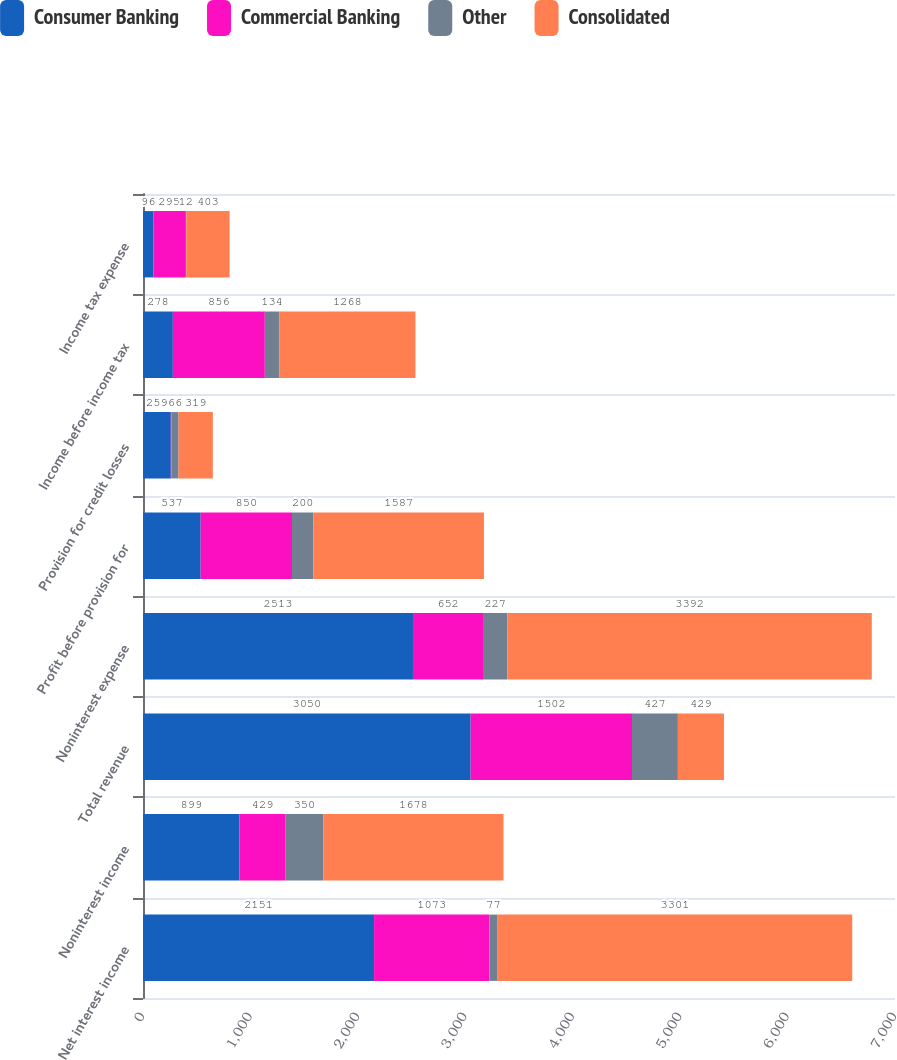Convert chart to OTSL. <chart><loc_0><loc_0><loc_500><loc_500><stacked_bar_chart><ecel><fcel>Net interest income<fcel>Noninterest income<fcel>Total revenue<fcel>Noninterest expense<fcel>Profit before provision for<fcel>Provision for credit losses<fcel>Income before income tax<fcel>Income tax expense<nl><fcel>Consumer Banking<fcel>2151<fcel>899<fcel>3050<fcel>2513<fcel>537<fcel>259<fcel>278<fcel>96<nl><fcel>Commercial Banking<fcel>1073<fcel>429<fcel>1502<fcel>652<fcel>850<fcel>6<fcel>856<fcel>295<nl><fcel>Other<fcel>77<fcel>350<fcel>427<fcel>227<fcel>200<fcel>66<fcel>134<fcel>12<nl><fcel>Consolidated<fcel>3301<fcel>1678<fcel>429<fcel>3392<fcel>1587<fcel>319<fcel>1268<fcel>403<nl></chart> 